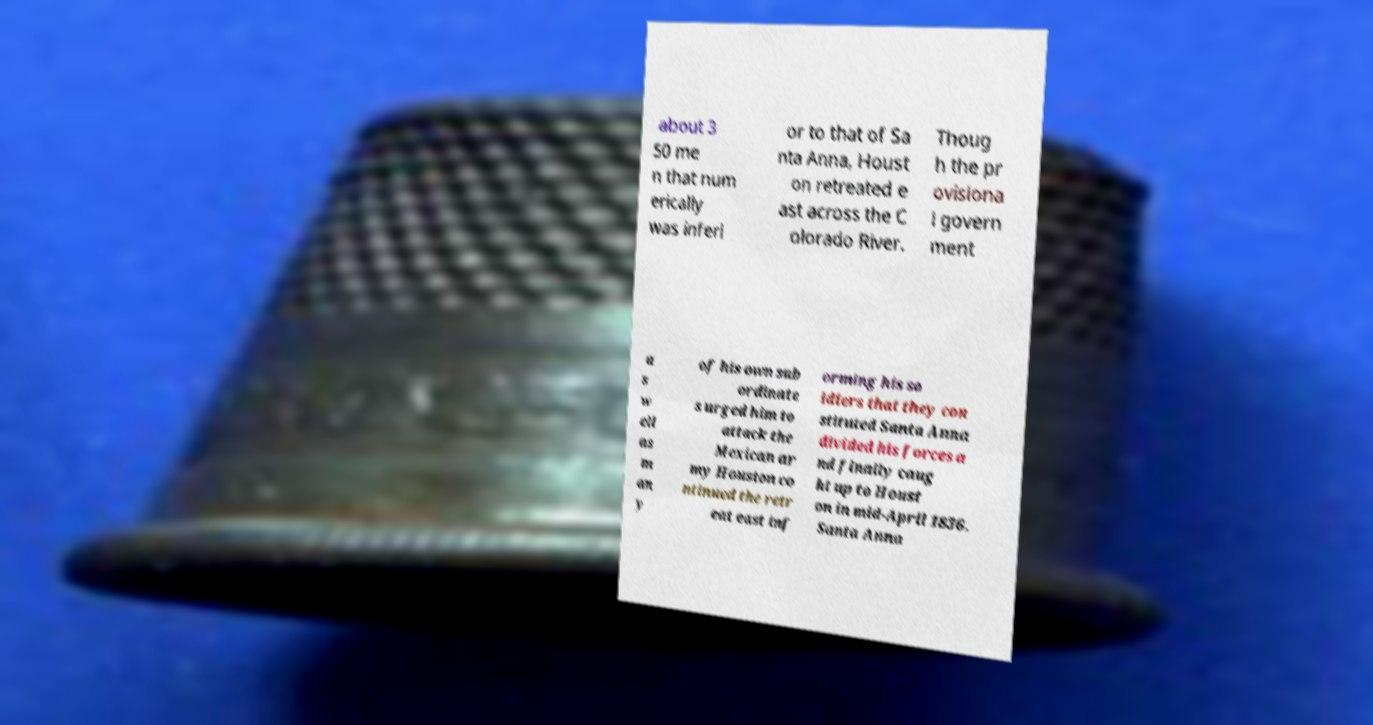Could you assist in decoding the text presented in this image and type it out clearly? about 3 50 me n that num erically was inferi or to that of Sa nta Anna, Houst on retreated e ast across the C olorado River. Thoug h the pr ovisiona l govern ment a s w ell as m an y of his own sub ordinate s urged him to attack the Mexican ar my Houston co ntinued the retr eat east inf orming his so ldiers that they con stituted Santa Anna divided his forces a nd finally caug ht up to Houst on in mid-April 1836. Santa Anna 